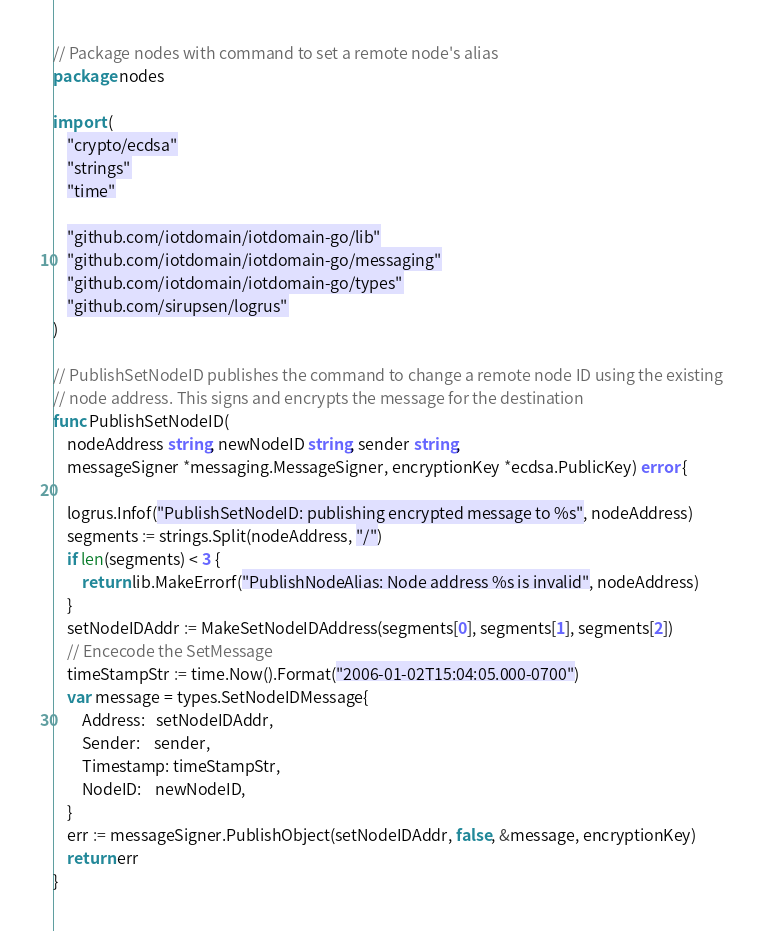<code> <loc_0><loc_0><loc_500><loc_500><_Go_>// Package nodes with command to set a remote node's alias
package nodes

import (
	"crypto/ecdsa"
	"strings"
	"time"

	"github.com/iotdomain/iotdomain-go/lib"
	"github.com/iotdomain/iotdomain-go/messaging"
	"github.com/iotdomain/iotdomain-go/types"
	"github.com/sirupsen/logrus"
)

// PublishSetNodeID publishes the command to change a remote node ID using the existing
// node address. This signs and encrypts the message for the destination
func PublishSetNodeID(
	nodeAddress string, newNodeID string, sender string,
	messageSigner *messaging.MessageSigner, encryptionKey *ecdsa.PublicKey) error {

	logrus.Infof("PublishSetNodeID: publishing encrypted message to %s", nodeAddress)
	segments := strings.Split(nodeAddress, "/")
	if len(segments) < 3 {
		return lib.MakeErrorf("PublishNodeAlias: Node address %s is invalid", nodeAddress)
	}
	setNodeIDAddr := MakeSetNodeIDAddress(segments[0], segments[1], segments[2])
	// Encecode the SetMessage
	timeStampStr := time.Now().Format("2006-01-02T15:04:05.000-0700")
	var message = types.SetNodeIDMessage{
		Address:   setNodeIDAddr,
		Sender:    sender,
		Timestamp: timeStampStr,
		NodeID:    newNodeID,
	}
	err := messageSigner.PublishObject(setNodeIDAddr, false, &message, encryptionKey)
	return err
}
</code> 